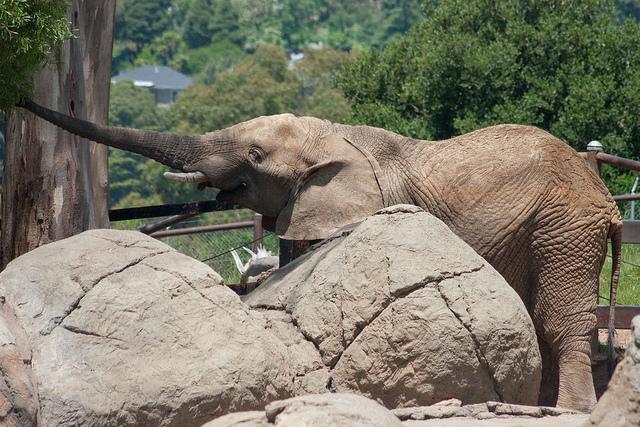Is this a pack animal?
Concise answer only. Yes. Is his trunk hanging down?
Write a very short answer. No. Is the elephant dancing?
Write a very short answer. No. What is the elephant standing behind?
Answer briefly. Rock. What is the animal doing?
Give a very brief answer. Eating. What animal is this?
Be succinct. Elephant. Is this a climbing scaffold?
Keep it brief. No. What is on top the elephant?
Concise answer only. Nothing. 